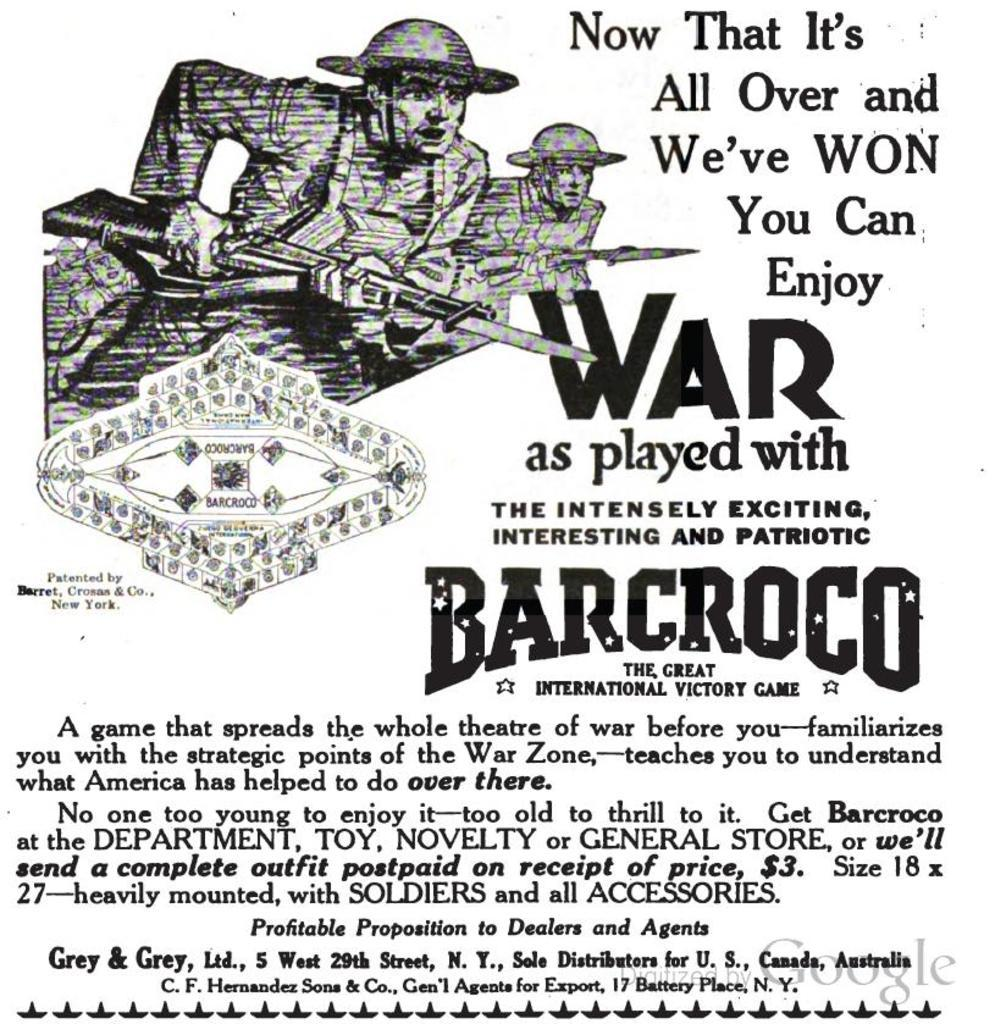<image>
Share a concise interpretation of the image provided. An advertisement for Barcroco shows army men with guns. 